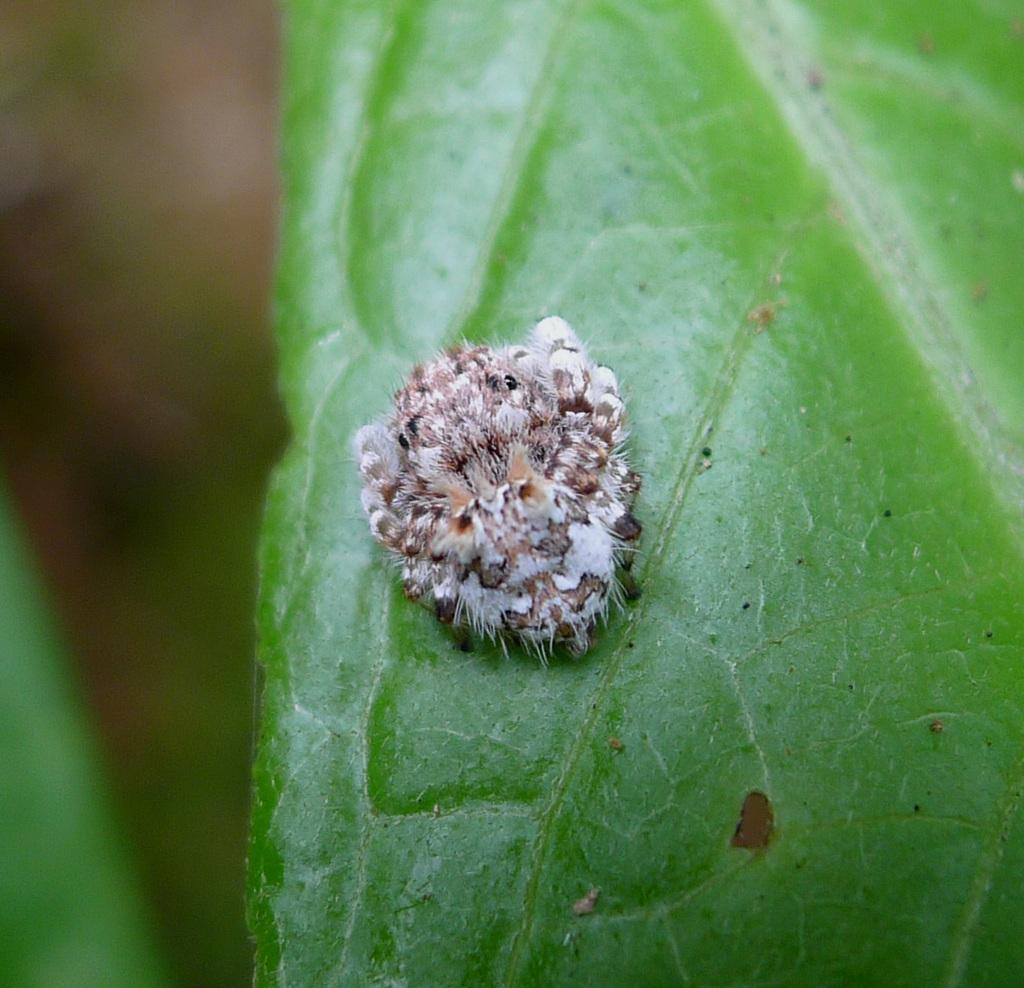What type of creature can be seen in the image? There is an insect in the image. Where is the insect located? The insect is on a green leaf. Can you describe the background of the image? The background of the image is blurry. What type of furniture can be seen in the image? There is no furniture present in the image; it features an insect on a green leaf with a blurry background. Can you tell me how many rabbits are visible in the image? There are no rabbits present in the image; it features an insect on a green leaf with a blurry background. 